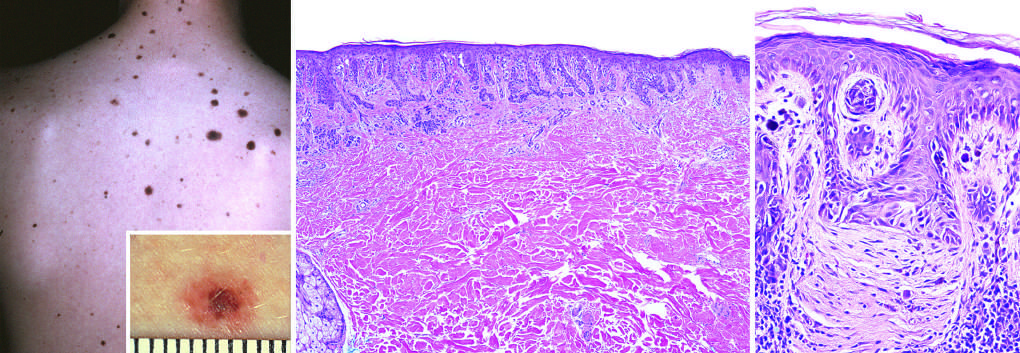does the latter correspond to the less pigmented flat peripheral rim?
Answer the question using a single word or phrase. Yes 